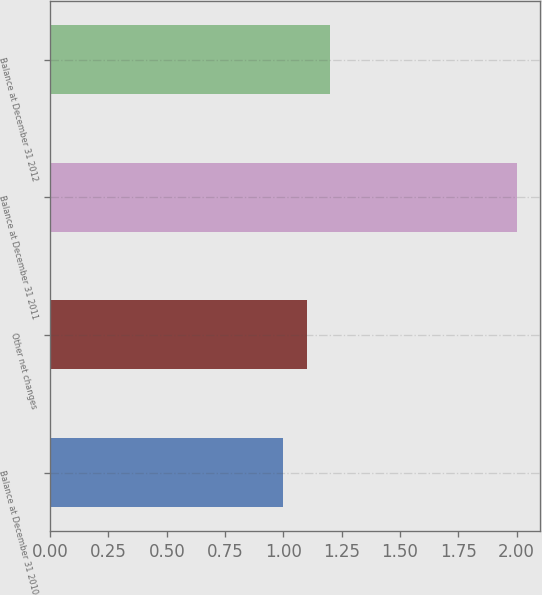Convert chart to OTSL. <chart><loc_0><loc_0><loc_500><loc_500><bar_chart><fcel>Balance at December 31 2010<fcel>Other net changes<fcel>Balance at December 31 2011<fcel>Balance at December 31 2012<nl><fcel>1<fcel>1.1<fcel>2<fcel>1.2<nl></chart> 